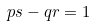Convert formula to latex. <formula><loc_0><loc_0><loc_500><loc_500>p s - q r = 1</formula> 